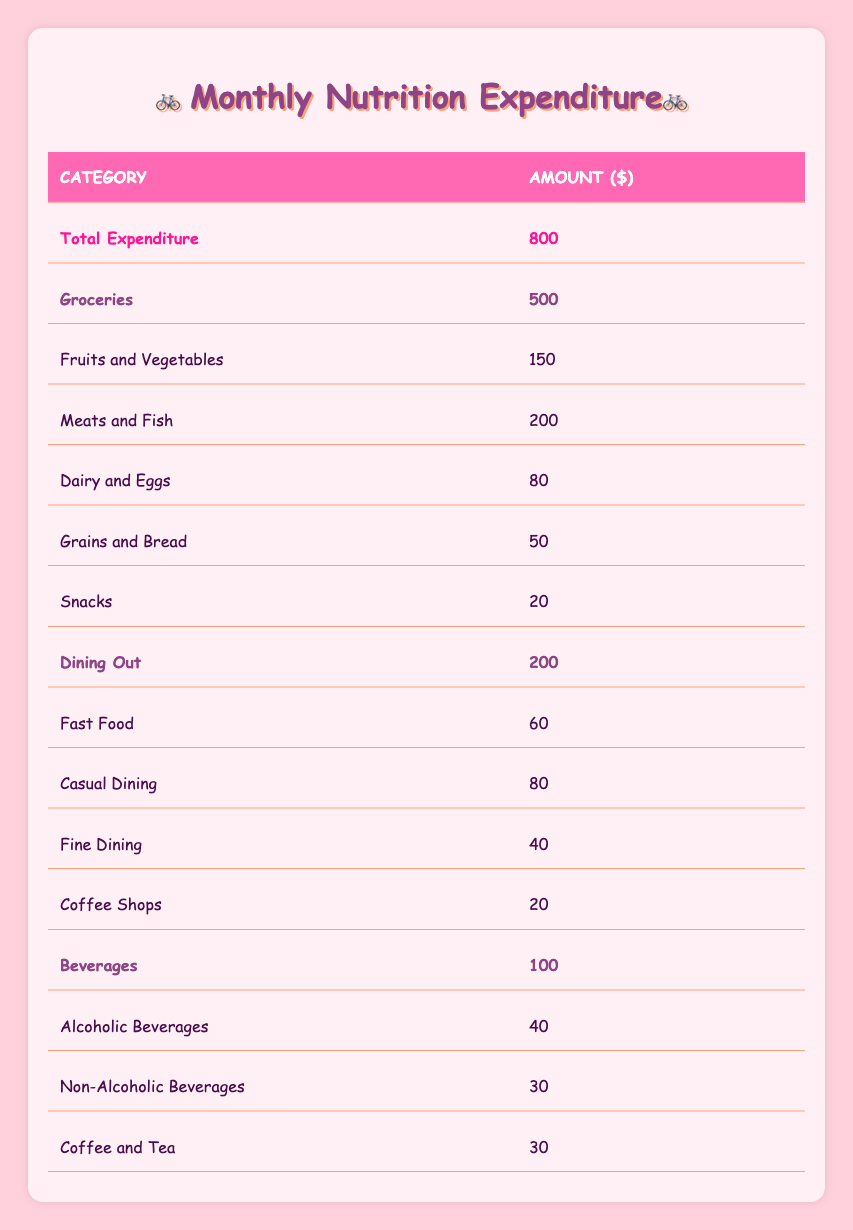What is the total monthly nutrition expenditure for a typical household? The total monthly nutrition expenditure is listed at the top of the table under Total Expenditure, which is 800.
Answer: 800 How much does a typical household spend on groceries? The groceries expenditure is found in the table under the category Groceries, which states the total is 500.
Answer: 500 What is the amount spent on dining out? The total for dining out can be found in the Dining Out category of the table, which is 200.
Answer: 200 Are more funds allocated to groceries than dining out? Groceries total 500 while dining out totals 200. Since 500 is greater than 200, it confirms that more is spent on groceries.
Answer: Yes What is the percentage of total expenditure spent on beverages? To calculate the percentage for beverages, we use the beverage total of 100 and total expenditure of 800. The formula is (100 / 800) * 100 = 12.5%.
Answer: 12.5% What is the total spent on snacks? The snacks expenditure is listed in the Groceries category under Snacks, which shows a total of 20.
Answer: 20 Which category has the highest expenditure, and what is that expenditure? Looking at each category, Groceries has 500, Dining Out has 200, and Beverages has 100. The highest is in the Groceries category at 500.
Answer: Groceries, 500 What is the total spent on non-alcoholic beverages and coffee and tea combined? We find the amount for non-alcoholic beverages as 30 and coffee and tea also as 30. Adding these gives us 30 + 30 = 60.
Answer: 60 How much is spent on meats and fish compared to dairy and eggs? The expenditure for meats and fish is 200, while for dairy and eggs it is 80. Comparing these, 200 is greater than 80, indicating more is spent on meats and fish.
Answer: More is spent on meats and fish 